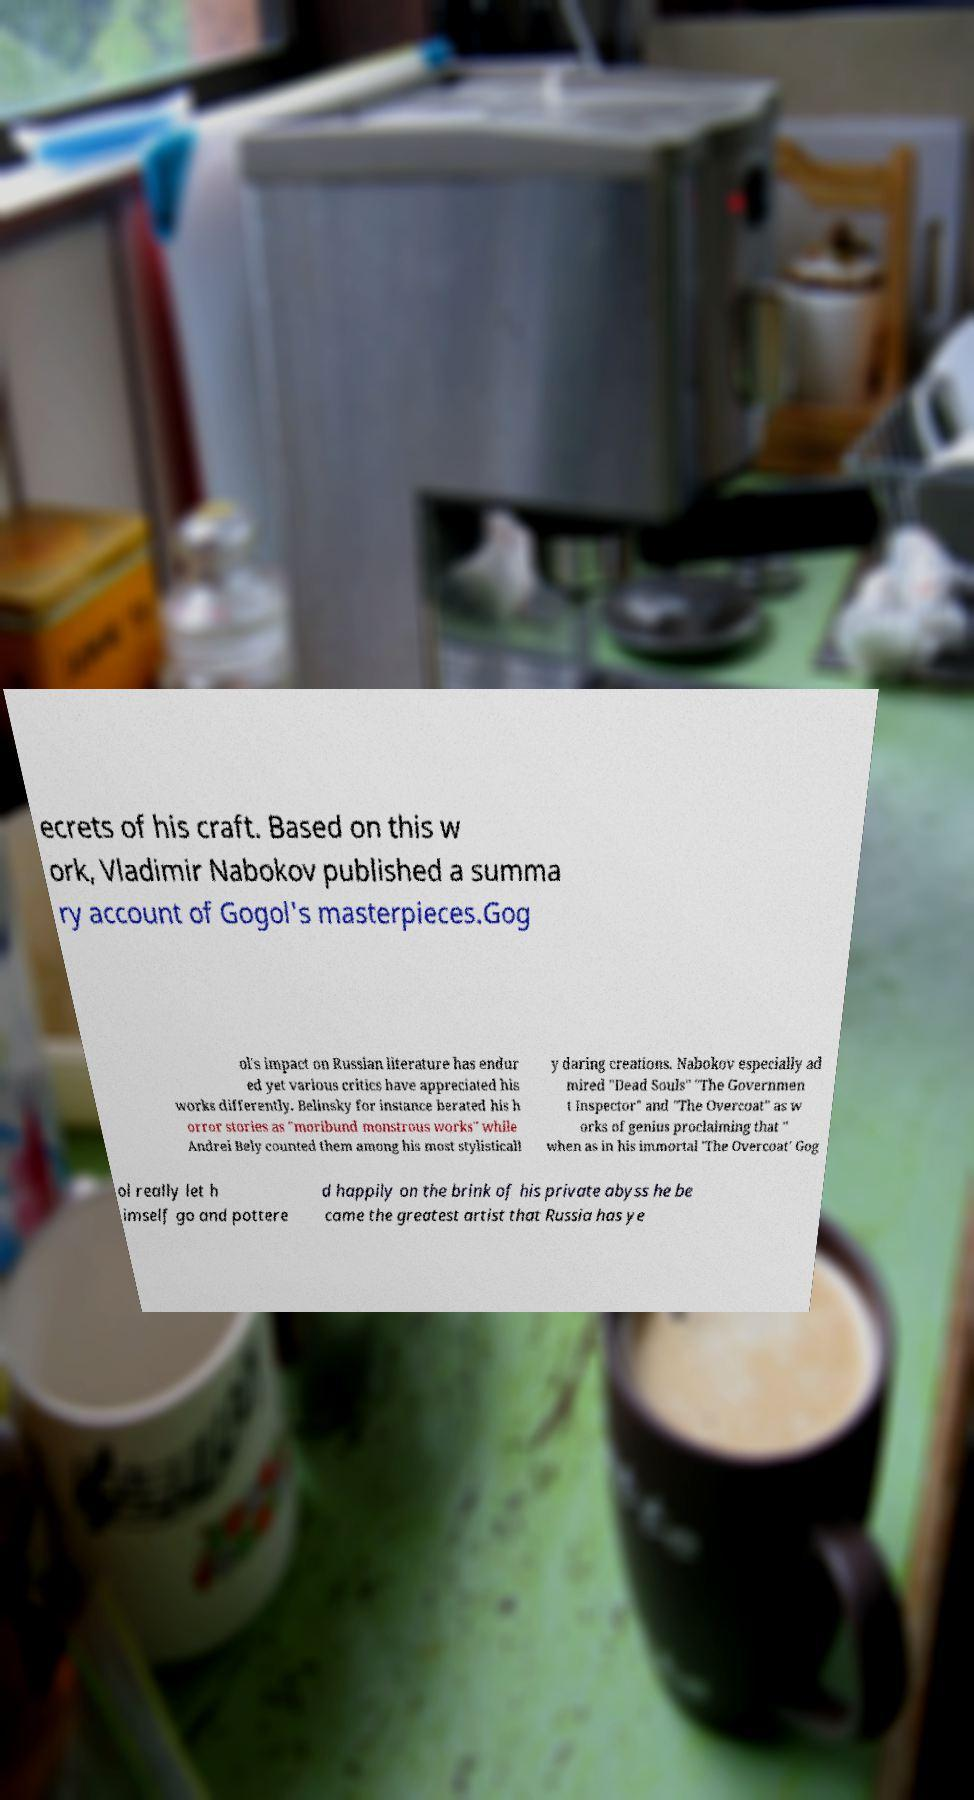Could you extract and type out the text from this image? ecrets of his craft. Based on this w ork, Vladimir Nabokov published a summa ry account of Gogol's masterpieces.Gog ol's impact on Russian literature has endur ed yet various critics have appreciated his works differently. Belinsky for instance berated his h orror stories as "moribund monstrous works" while Andrei Bely counted them among his most stylisticall y daring creations. Nabokov especially ad mired "Dead Souls" "The Governmen t Inspector" and "The Overcoat" as w orks of genius proclaiming that " when as in his immortal 'The Overcoat' Gog ol really let h imself go and pottere d happily on the brink of his private abyss he be came the greatest artist that Russia has ye 